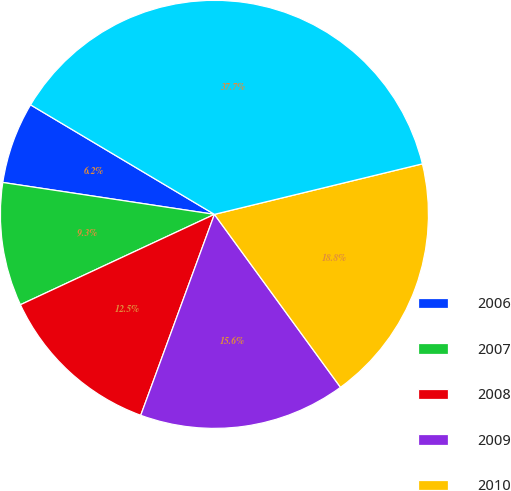Convert chart. <chart><loc_0><loc_0><loc_500><loc_500><pie_chart><fcel>2006<fcel>2007<fcel>2008<fcel>2009<fcel>2010<fcel>2011 through 2015<nl><fcel>6.17%<fcel>9.32%<fcel>12.47%<fcel>15.62%<fcel>18.77%<fcel>37.66%<nl></chart> 